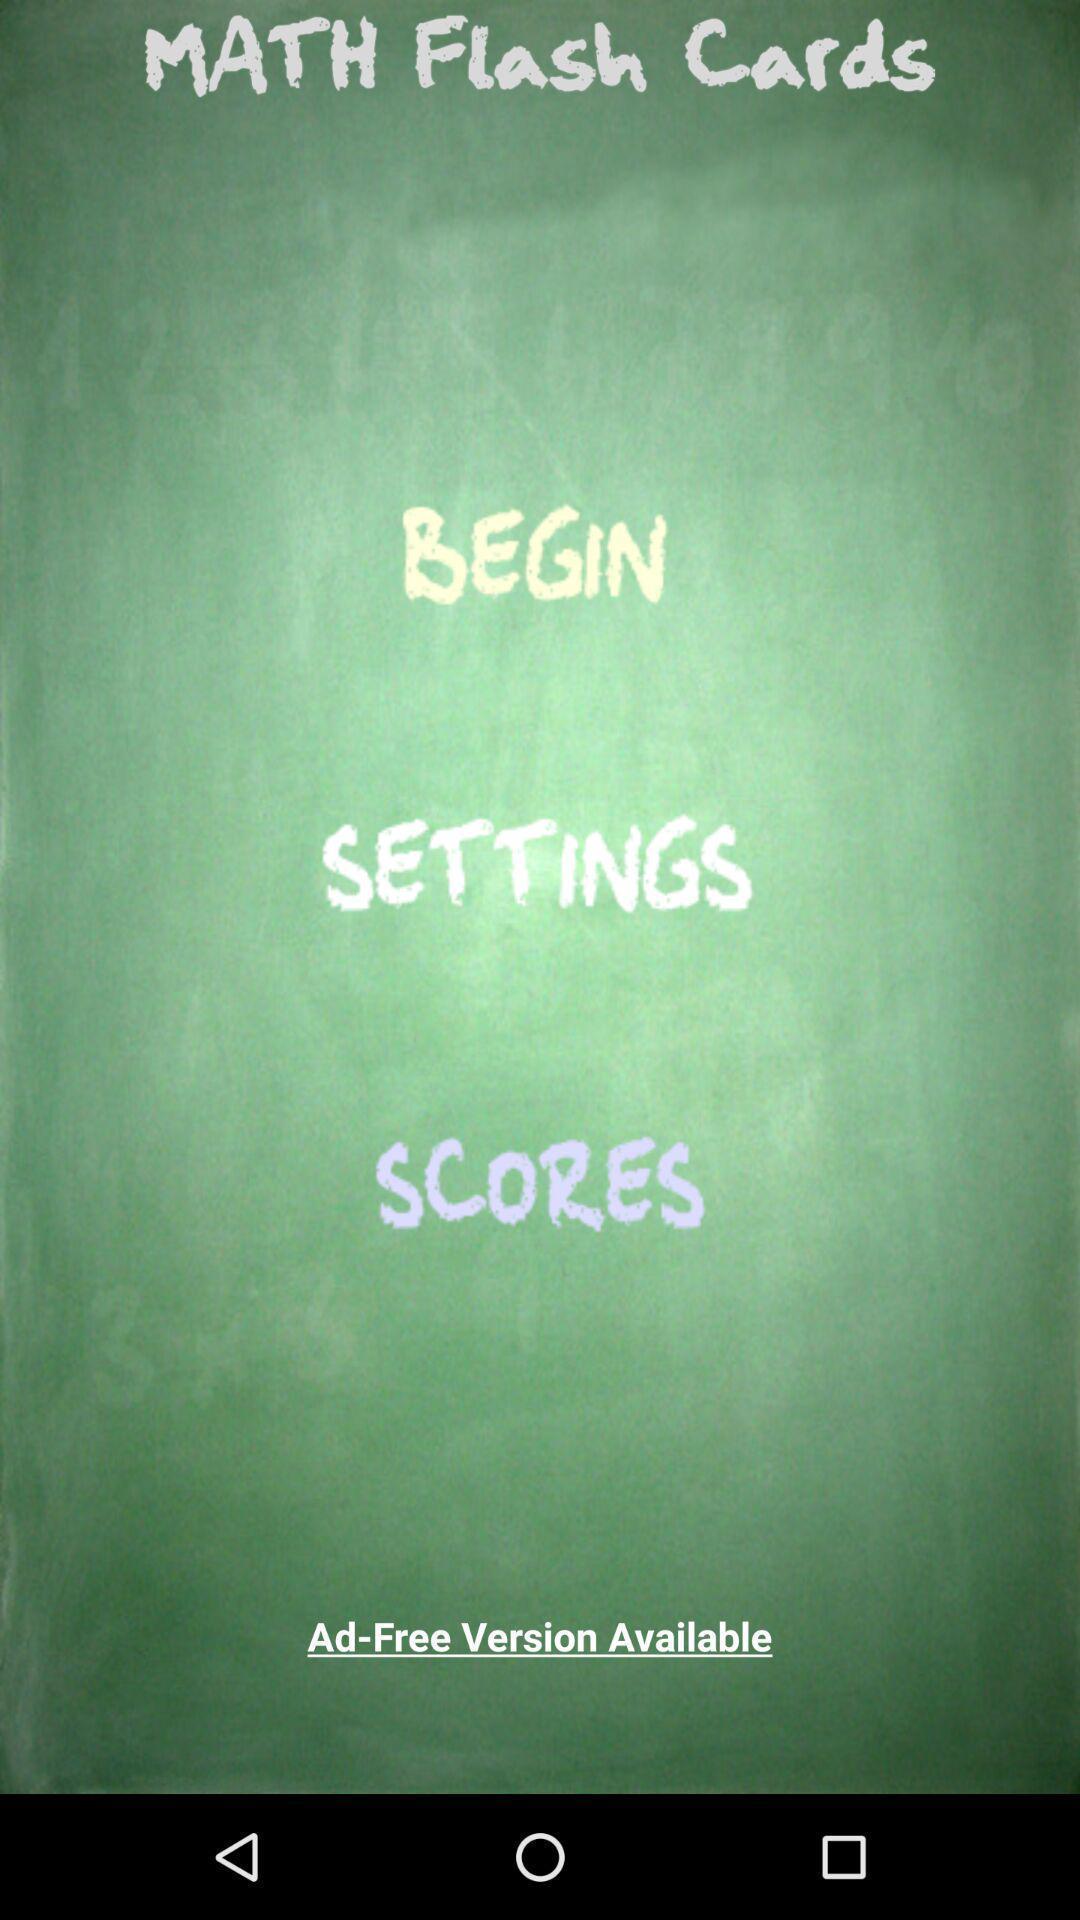Provide a textual representation of this image. Welcome page of learning app. 